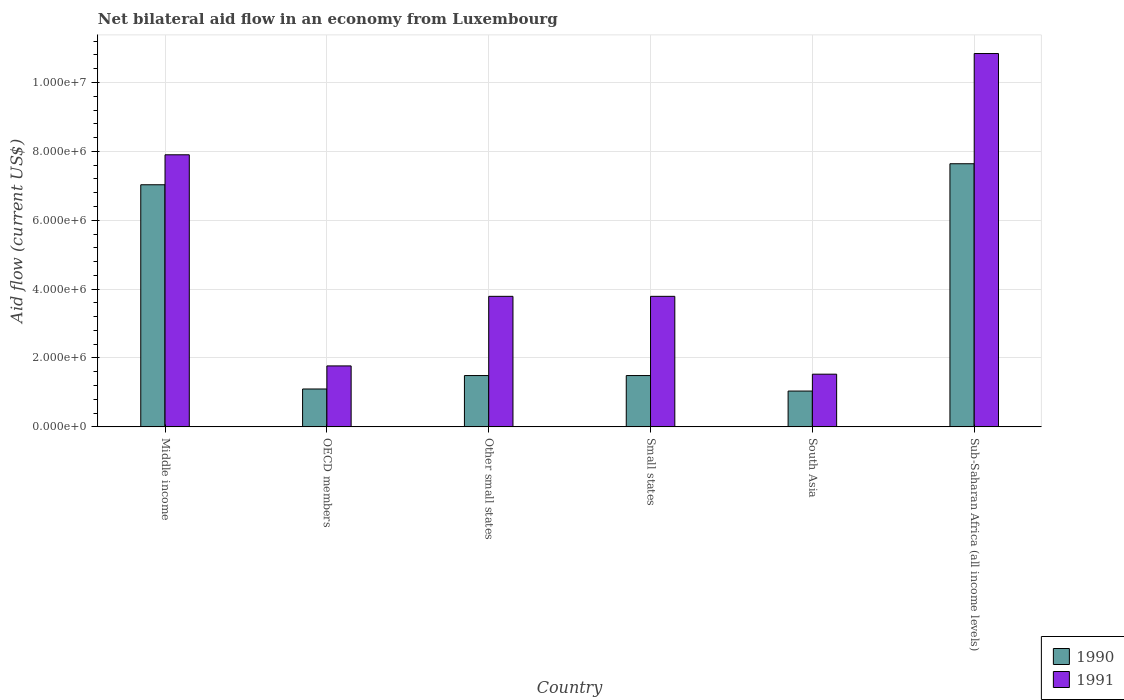How many different coloured bars are there?
Provide a short and direct response. 2. How many groups of bars are there?
Provide a short and direct response. 6. Are the number of bars on each tick of the X-axis equal?
Make the answer very short. Yes. How many bars are there on the 5th tick from the left?
Keep it short and to the point. 2. How many bars are there on the 3rd tick from the right?
Provide a short and direct response. 2. What is the net bilateral aid flow in 1991 in Small states?
Your response must be concise. 3.79e+06. Across all countries, what is the maximum net bilateral aid flow in 1990?
Your answer should be very brief. 7.64e+06. Across all countries, what is the minimum net bilateral aid flow in 1991?
Offer a very short reply. 1.53e+06. In which country was the net bilateral aid flow in 1991 maximum?
Your answer should be very brief. Sub-Saharan Africa (all income levels). What is the total net bilateral aid flow in 1990 in the graph?
Offer a terse response. 1.98e+07. What is the difference between the net bilateral aid flow in 1991 in OECD members and that in Small states?
Provide a succinct answer. -2.02e+06. What is the difference between the net bilateral aid flow in 1990 in Middle income and the net bilateral aid flow in 1991 in South Asia?
Make the answer very short. 5.50e+06. What is the average net bilateral aid flow in 1991 per country?
Offer a very short reply. 4.94e+06. What is the difference between the net bilateral aid flow of/in 1991 and net bilateral aid flow of/in 1990 in OECD members?
Provide a succinct answer. 6.70e+05. In how many countries, is the net bilateral aid flow in 1991 greater than 1600000 US$?
Offer a terse response. 5. What is the ratio of the net bilateral aid flow in 1991 in South Asia to that in Sub-Saharan Africa (all income levels)?
Offer a terse response. 0.14. What is the difference between the highest and the second highest net bilateral aid flow in 1991?
Provide a short and direct response. 2.94e+06. What is the difference between the highest and the lowest net bilateral aid flow in 1990?
Make the answer very short. 6.60e+06. In how many countries, is the net bilateral aid flow in 1991 greater than the average net bilateral aid flow in 1991 taken over all countries?
Make the answer very short. 2. How many countries are there in the graph?
Ensure brevity in your answer.  6. What is the difference between two consecutive major ticks on the Y-axis?
Keep it short and to the point. 2.00e+06. Does the graph contain grids?
Keep it short and to the point. Yes. How many legend labels are there?
Keep it short and to the point. 2. How are the legend labels stacked?
Give a very brief answer. Vertical. What is the title of the graph?
Provide a succinct answer. Net bilateral aid flow in an economy from Luxembourg. Does "2009" appear as one of the legend labels in the graph?
Your answer should be compact. No. What is the Aid flow (current US$) in 1990 in Middle income?
Provide a short and direct response. 7.03e+06. What is the Aid flow (current US$) of 1991 in Middle income?
Ensure brevity in your answer.  7.90e+06. What is the Aid flow (current US$) in 1990 in OECD members?
Ensure brevity in your answer.  1.10e+06. What is the Aid flow (current US$) in 1991 in OECD members?
Provide a short and direct response. 1.77e+06. What is the Aid flow (current US$) in 1990 in Other small states?
Your response must be concise. 1.49e+06. What is the Aid flow (current US$) in 1991 in Other small states?
Keep it short and to the point. 3.79e+06. What is the Aid flow (current US$) in 1990 in Small states?
Keep it short and to the point. 1.49e+06. What is the Aid flow (current US$) of 1991 in Small states?
Provide a short and direct response. 3.79e+06. What is the Aid flow (current US$) of 1990 in South Asia?
Your response must be concise. 1.04e+06. What is the Aid flow (current US$) of 1991 in South Asia?
Make the answer very short. 1.53e+06. What is the Aid flow (current US$) in 1990 in Sub-Saharan Africa (all income levels)?
Provide a succinct answer. 7.64e+06. What is the Aid flow (current US$) in 1991 in Sub-Saharan Africa (all income levels)?
Your answer should be very brief. 1.08e+07. Across all countries, what is the maximum Aid flow (current US$) in 1990?
Provide a succinct answer. 7.64e+06. Across all countries, what is the maximum Aid flow (current US$) of 1991?
Your answer should be compact. 1.08e+07. Across all countries, what is the minimum Aid flow (current US$) in 1990?
Make the answer very short. 1.04e+06. Across all countries, what is the minimum Aid flow (current US$) in 1991?
Make the answer very short. 1.53e+06. What is the total Aid flow (current US$) of 1990 in the graph?
Your response must be concise. 1.98e+07. What is the total Aid flow (current US$) of 1991 in the graph?
Offer a very short reply. 2.96e+07. What is the difference between the Aid flow (current US$) of 1990 in Middle income and that in OECD members?
Give a very brief answer. 5.93e+06. What is the difference between the Aid flow (current US$) in 1991 in Middle income and that in OECD members?
Your answer should be compact. 6.13e+06. What is the difference between the Aid flow (current US$) in 1990 in Middle income and that in Other small states?
Provide a short and direct response. 5.54e+06. What is the difference between the Aid flow (current US$) of 1991 in Middle income and that in Other small states?
Your response must be concise. 4.11e+06. What is the difference between the Aid flow (current US$) of 1990 in Middle income and that in Small states?
Keep it short and to the point. 5.54e+06. What is the difference between the Aid flow (current US$) of 1991 in Middle income and that in Small states?
Offer a terse response. 4.11e+06. What is the difference between the Aid flow (current US$) in 1990 in Middle income and that in South Asia?
Offer a terse response. 5.99e+06. What is the difference between the Aid flow (current US$) in 1991 in Middle income and that in South Asia?
Your response must be concise. 6.37e+06. What is the difference between the Aid flow (current US$) in 1990 in Middle income and that in Sub-Saharan Africa (all income levels)?
Your answer should be compact. -6.10e+05. What is the difference between the Aid flow (current US$) in 1991 in Middle income and that in Sub-Saharan Africa (all income levels)?
Your answer should be compact. -2.94e+06. What is the difference between the Aid flow (current US$) of 1990 in OECD members and that in Other small states?
Provide a succinct answer. -3.90e+05. What is the difference between the Aid flow (current US$) of 1991 in OECD members and that in Other small states?
Your response must be concise. -2.02e+06. What is the difference between the Aid flow (current US$) in 1990 in OECD members and that in Small states?
Offer a terse response. -3.90e+05. What is the difference between the Aid flow (current US$) of 1991 in OECD members and that in Small states?
Your response must be concise. -2.02e+06. What is the difference between the Aid flow (current US$) of 1990 in OECD members and that in Sub-Saharan Africa (all income levels)?
Provide a short and direct response. -6.54e+06. What is the difference between the Aid flow (current US$) in 1991 in OECD members and that in Sub-Saharan Africa (all income levels)?
Make the answer very short. -9.07e+06. What is the difference between the Aid flow (current US$) of 1990 in Other small states and that in Small states?
Offer a very short reply. 0. What is the difference between the Aid flow (current US$) of 1991 in Other small states and that in Small states?
Ensure brevity in your answer.  0. What is the difference between the Aid flow (current US$) of 1990 in Other small states and that in South Asia?
Your answer should be compact. 4.50e+05. What is the difference between the Aid flow (current US$) of 1991 in Other small states and that in South Asia?
Make the answer very short. 2.26e+06. What is the difference between the Aid flow (current US$) in 1990 in Other small states and that in Sub-Saharan Africa (all income levels)?
Your answer should be compact. -6.15e+06. What is the difference between the Aid flow (current US$) in 1991 in Other small states and that in Sub-Saharan Africa (all income levels)?
Keep it short and to the point. -7.05e+06. What is the difference between the Aid flow (current US$) of 1990 in Small states and that in South Asia?
Your response must be concise. 4.50e+05. What is the difference between the Aid flow (current US$) of 1991 in Small states and that in South Asia?
Provide a short and direct response. 2.26e+06. What is the difference between the Aid flow (current US$) in 1990 in Small states and that in Sub-Saharan Africa (all income levels)?
Provide a short and direct response. -6.15e+06. What is the difference between the Aid flow (current US$) of 1991 in Small states and that in Sub-Saharan Africa (all income levels)?
Offer a very short reply. -7.05e+06. What is the difference between the Aid flow (current US$) in 1990 in South Asia and that in Sub-Saharan Africa (all income levels)?
Your answer should be very brief. -6.60e+06. What is the difference between the Aid flow (current US$) of 1991 in South Asia and that in Sub-Saharan Africa (all income levels)?
Offer a terse response. -9.31e+06. What is the difference between the Aid flow (current US$) in 1990 in Middle income and the Aid flow (current US$) in 1991 in OECD members?
Keep it short and to the point. 5.26e+06. What is the difference between the Aid flow (current US$) in 1990 in Middle income and the Aid flow (current US$) in 1991 in Other small states?
Your answer should be compact. 3.24e+06. What is the difference between the Aid flow (current US$) of 1990 in Middle income and the Aid flow (current US$) of 1991 in Small states?
Offer a very short reply. 3.24e+06. What is the difference between the Aid flow (current US$) in 1990 in Middle income and the Aid flow (current US$) in 1991 in South Asia?
Your answer should be compact. 5.50e+06. What is the difference between the Aid flow (current US$) in 1990 in Middle income and the Aid flow (current US$) in 1991 in Sub-Saharan Africa (all income levels)?
Your response must be concise. -3.81e+06. What is the difference between the Aid flow (current US$) in 1990 in OECD members and the Aid flow (current US$) in 1991 in Other small states?
Give a very brief answer. -2.69e+06. What is the difference between the Aid flow (current US$) in 1990 in OECD members and the Aid flow (current US$) in 1991 in Small states?
Keep it short and to the point. -2.69e+06. What is the difference between the Aid flow (current US$) in 1990 in OECD members and the Aid flow (current US$) in 1991 in South Asia?
Your answer should be compact. -4.30e+05. What is the difference between the Aid flow (current US$) in 1990 in OECD members and the Aid flow (current US$) in 1991 in Sub-Saharan Africa (all income levels)?
Offer a terse response. -9.74e+06. What is the difference between the Aid flow (current US$) in 1990 in Other small states and the Aid flow (current US$) in 1991 in Small states?
Offer a terse response. -2.30e+06. What is the difference between the Aid flow (current US$) of 1990 in Other small states and the Aid flow (current US$) of 1991 in South Asia?
Offer a very short reply. -4.00e+04. What is the difference between the Aid flow (current US$) in 1990 in Other small states and the Aid flow (current US$) in 1991 in Sub-Saharan Africa (all income levels)?
Your response must be concise. -9.35e+06. What is the difference between the Aid flow (current US$) of 1990 in Small states and the Aid flow (current US$) of 1991 in Sub-Saharan Africa (all income levels)?
Your answer should be compact. -9.35e+06. What is the difference between the Aid flow (current US$) in 1990 in South Asia and the Aid flow (current US$) in 1991 in Sub-Saharan Africa (all income levels)?
Your answer should be very brief. -9.80e+06. What is the average Aid flow (current US$) of 1990 per country?
Offer a very short reply. 3.30e+06. What is the average Aid flow (current US$) in 1991 per country?
Offer a terse response. 4.94e+06. What is the difference between the Aid flow (current US$) of 1990 and Aid flow (current US$) of 1991 in Middle income?
Keep it short and to the point. -8.70e+05. What is the difference between the Aid flow (current US$) of 1990 and Aid flow (current US$) of 1991 in OECD members?
Provide a succinct answer. -6.70e+05. What is the difference between the Aid flow (current US$) of 1990 and Aid flow (current US$) of 1991 in Other small states?
Offer a terse response. -2.30e+06. What is the difference between the Aid flow (current US$) of 1990 and Aid flow (current US$) of 1991 in Small states?
Provide a short and direct response. -2.30e+06. What is the difference between the Aid flow (current US$) in 1990 and Aid flow (current US$) in 1991 in South Asia?
Give a very brief answer. -4.90e+05. What is the difference between the Aid flow (current US$) of 1990 and Aid flow (current US$) of 1991 in Sub-Saharan Africa (all income levels)?
Keep it short and to the point. -3.20e+06. What is the ratio of the Aid flow (current US$) of 1990 in Middle income to that in OECD members?
Your answer should be compact. 6.39. What is the ratio of the Aid flow (current US$) of 1991 in Middle income to that in OECD members?
Ensure brevity in your answer.  4.46. What is the ratio of the Aid flow (current US$) in 1990 in Middle income to that in Other small states?
Your response must be concise. 4.72. What is the ratio of the Aid flow (current US$) in 1991 in Middle income to that in Other small states?
Offer a very short reply. 2.08. What is the ratio of the Aid flow (current US$) of 1990 in Middle income to that in Small states?
Provide a short and direct response. 4.72. What is the ratio of the Aid flow (current US$) of 1991 in Middle income to that in Small states?
Give a very brief answer. 2.08. What is the ratio of the Aid flow (current US$) in 1990 in Middle income to that in South Asia?
Your response must be concise. 6.76. What is the ratio of the Aid flow (current US$) in 1991 in Middle income to that in South Asia?
Provide a short and direct response. 5.16. What is the ratio of the Aid flow (current US$) in 1990 in Middle income to that in Sub-Saharan Africa (all income levels)?
Give a very brief answer. 0.92. What is the ratio of the Aid flow (current US$) of 1991 in Middle income to that in Sub-Saharan Africa (all income levels)?
Offer a very short reply. 0.73. What is the ratio of the Aid flow (current US$) of 1990 in OECD members to that in Other small states?
Your answer should be very brief. 0.74. What is the ratio of the Aid flow (current US$) of 1991 in OECD members to that in Other small states?
Make the answer very short. 0.47. What is the ratio of the Aid flow (current US$) in 1990 in OECD members to that in Small states?
Ensure brevity in your answer.  0.74. What is the ratio of the Aid flow (current US$) in 1991 in OECD members to that in Small states?
Offer a very short reply. 0.47. What is the ratio of the Aid flow (current US$) in 1990 in OECD members to that in South Asia?
Your answer should be very brief. 1.06. What is the ratio of the Aid flow (current US$) of 1991 in OECD members to that in South Asia?
Offer a very short reply. 1.16. What is the ratio of the Aid flow (current US$) of 1990 in OECD members to that in Sub-Saharan Africa (all income levels)?
Provide a short and direct response. 0.14. What is the ratio of the Aid flow (current US$) in 1991 in OECD members to that in Sub-Saharan Africa (all income levels)?
Your answer should be compact. 0.16. What is the ratio of the Aid flow (current US$) of 1990 in Other small states to that in South Asia?
Your answer should be compact. 1.43. What is the ratio of the Aid flow (current US$) in 1991 in Other small states to that in South Asia?
Your answer should be very brief. 2.48. What is the ratio of the Aid flow (current US$) in 1990 in Other small states to that in Sub-Saharan Africa (all income levels)?
Your answer should be compact. 0.2. What is the ratio of the Aid flow (current US$) of 1991 in Other small states to that in Sub-Saharan Africa (all income levels)?
Your answer should be very brief. 0.35. What is the ratio of the Aid flow (current US$) of 1990 in Small states to that in South Asia?
Offer a very short reply. 1.43. What is the ratio of the Aid flow (current US$) in 1991 in Small states to that in South Asia?
Provide a short and direct response. 2.48. What is the ratio of the Aid flow (current US$) of 1990 in Small states to that in Sub-Saharan Africa (all income levels)?
Offer a terse response. 0.2. What is the ratio of the Aid flow (current US$) of 1991 in Small states to that in Sub-Saharan Africa (all income levels)?
Offer a terse response. 0.35. What is the ratio of the Aid flow (current US$) in 1990 in South Asia to that in Sub-Saharan Africa (all income levels)?
Your answer should be compact. 0.14. What is the ratio of the Aid flow (current US$) in 1991 in South Asia to that in Sub-Saharan Africa (all income levels)?
Offer a terse response. 0.14. What is the difference between the highest and the second highest Aid flow (current US$) of 1991?
Your answer should be compact. 2.94e+06. What is the difference between the highest and the lowest Aid flow (current US$) of 1990?
Your answer should be very brief. 6.60e+06. What is the difference between the highest and the lowest Aid flow (current US$) of 1991?
Your answer should be compact. 9.31e+06. 